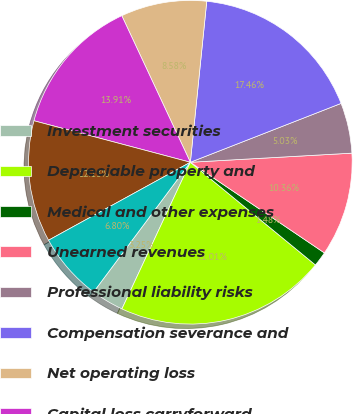Convert chart. <chart><loc_0><loc_0><loc_500><loc_500><pie_chart><fcel>Investment securities<fcel>Depreciable property and<fcel>Medical and other expenses<fcel>Unearned revenues<fcel>Professional liability risks<fcel>Compensation severance and<fcel>Net operating loss<fcel>Capital loss carryforward<fcel>Valuation allowance-capital<fcel>Total net deferred income tax<nl><fcel>3.25%<fcel>21.01%<fcel>1.48%<fcel>10.36%<fcel>5.03%<fcel>17.46%<fcel>8.58%<fcel>13.91%<fcel>12.13%<fcel>6.8%<nl></chart> 